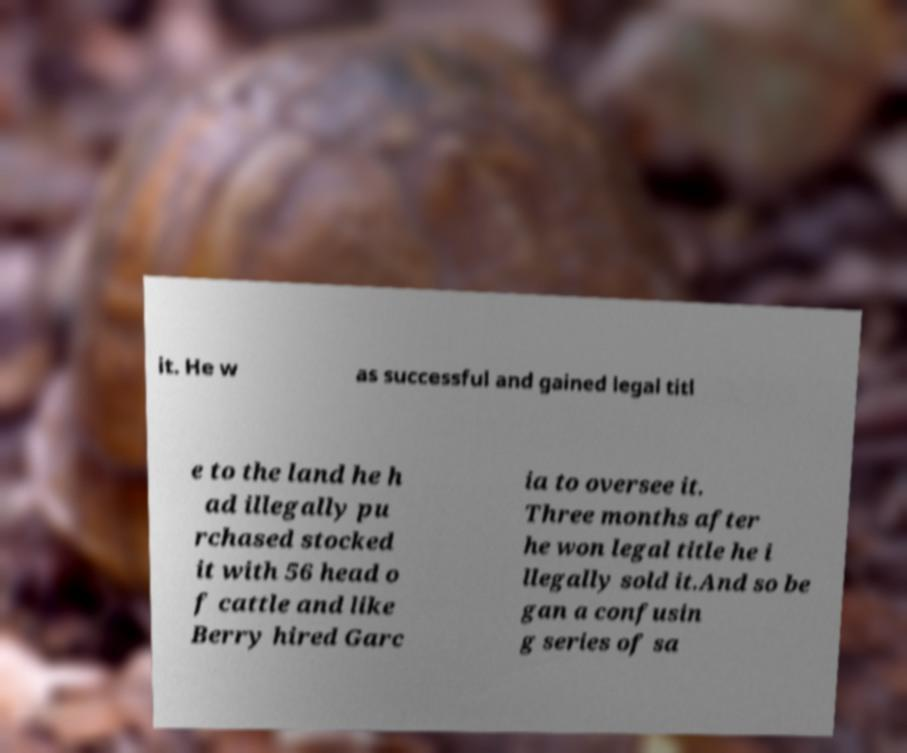I need the written content from this picture converted into text. Can you do that? it. He w as successful and gained legal titl e to the land he h ad illegally pu rchased stocked it with 56 head o f cattle and like Berry hired Garc ia to oversee it. Three months after he won legal title he i llegally sold it.And so be gan a confusin g series of sa 